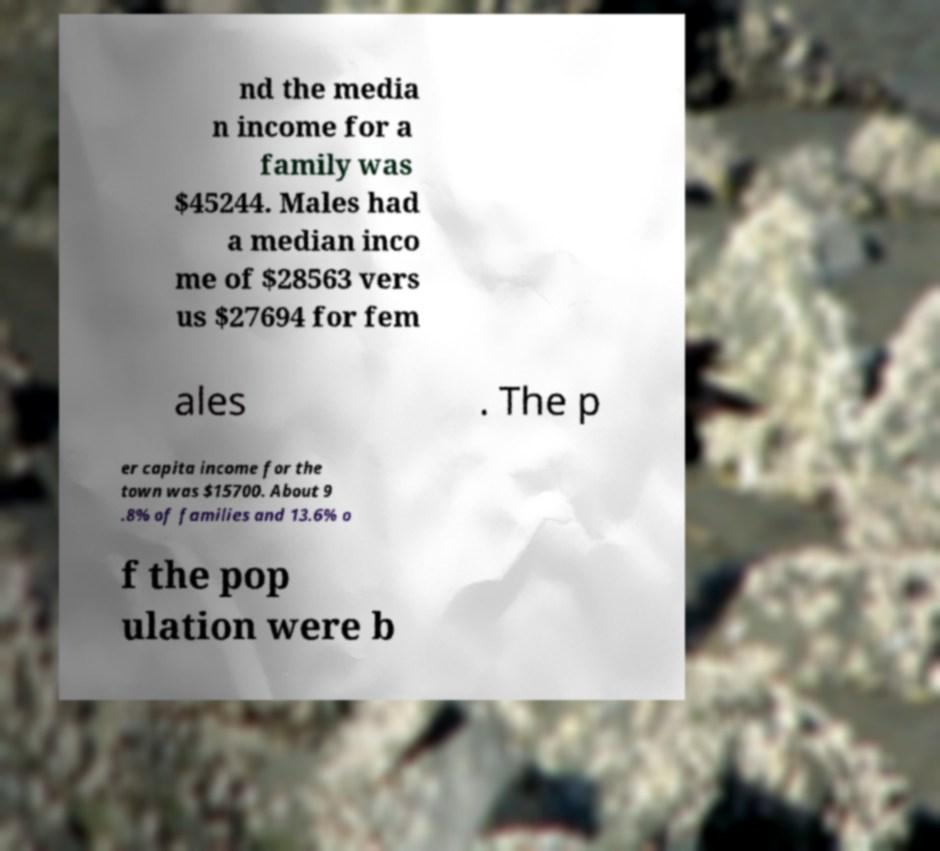What messages or text are displayed in this image? I need them in a readable, typed format. nd the media n income for a family was $45244. Males had a median inco me of $28563 vers us $27694 for fem ales . The p er capita income for the town was $15700. About 9 .8% of families and 13.6% o f the pop ulation were b 